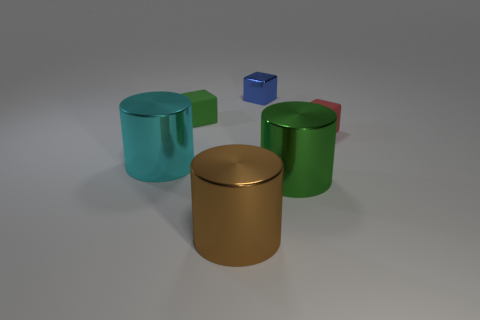Assuming these objects were part of an art installation, what theme could they represent? These objects could represent a theme of minimalism and simplicity in modern art, emphasizing basic geometric forms and solid colors to evoke contemplation on form and space without the distraction of complex patterns or designs. 